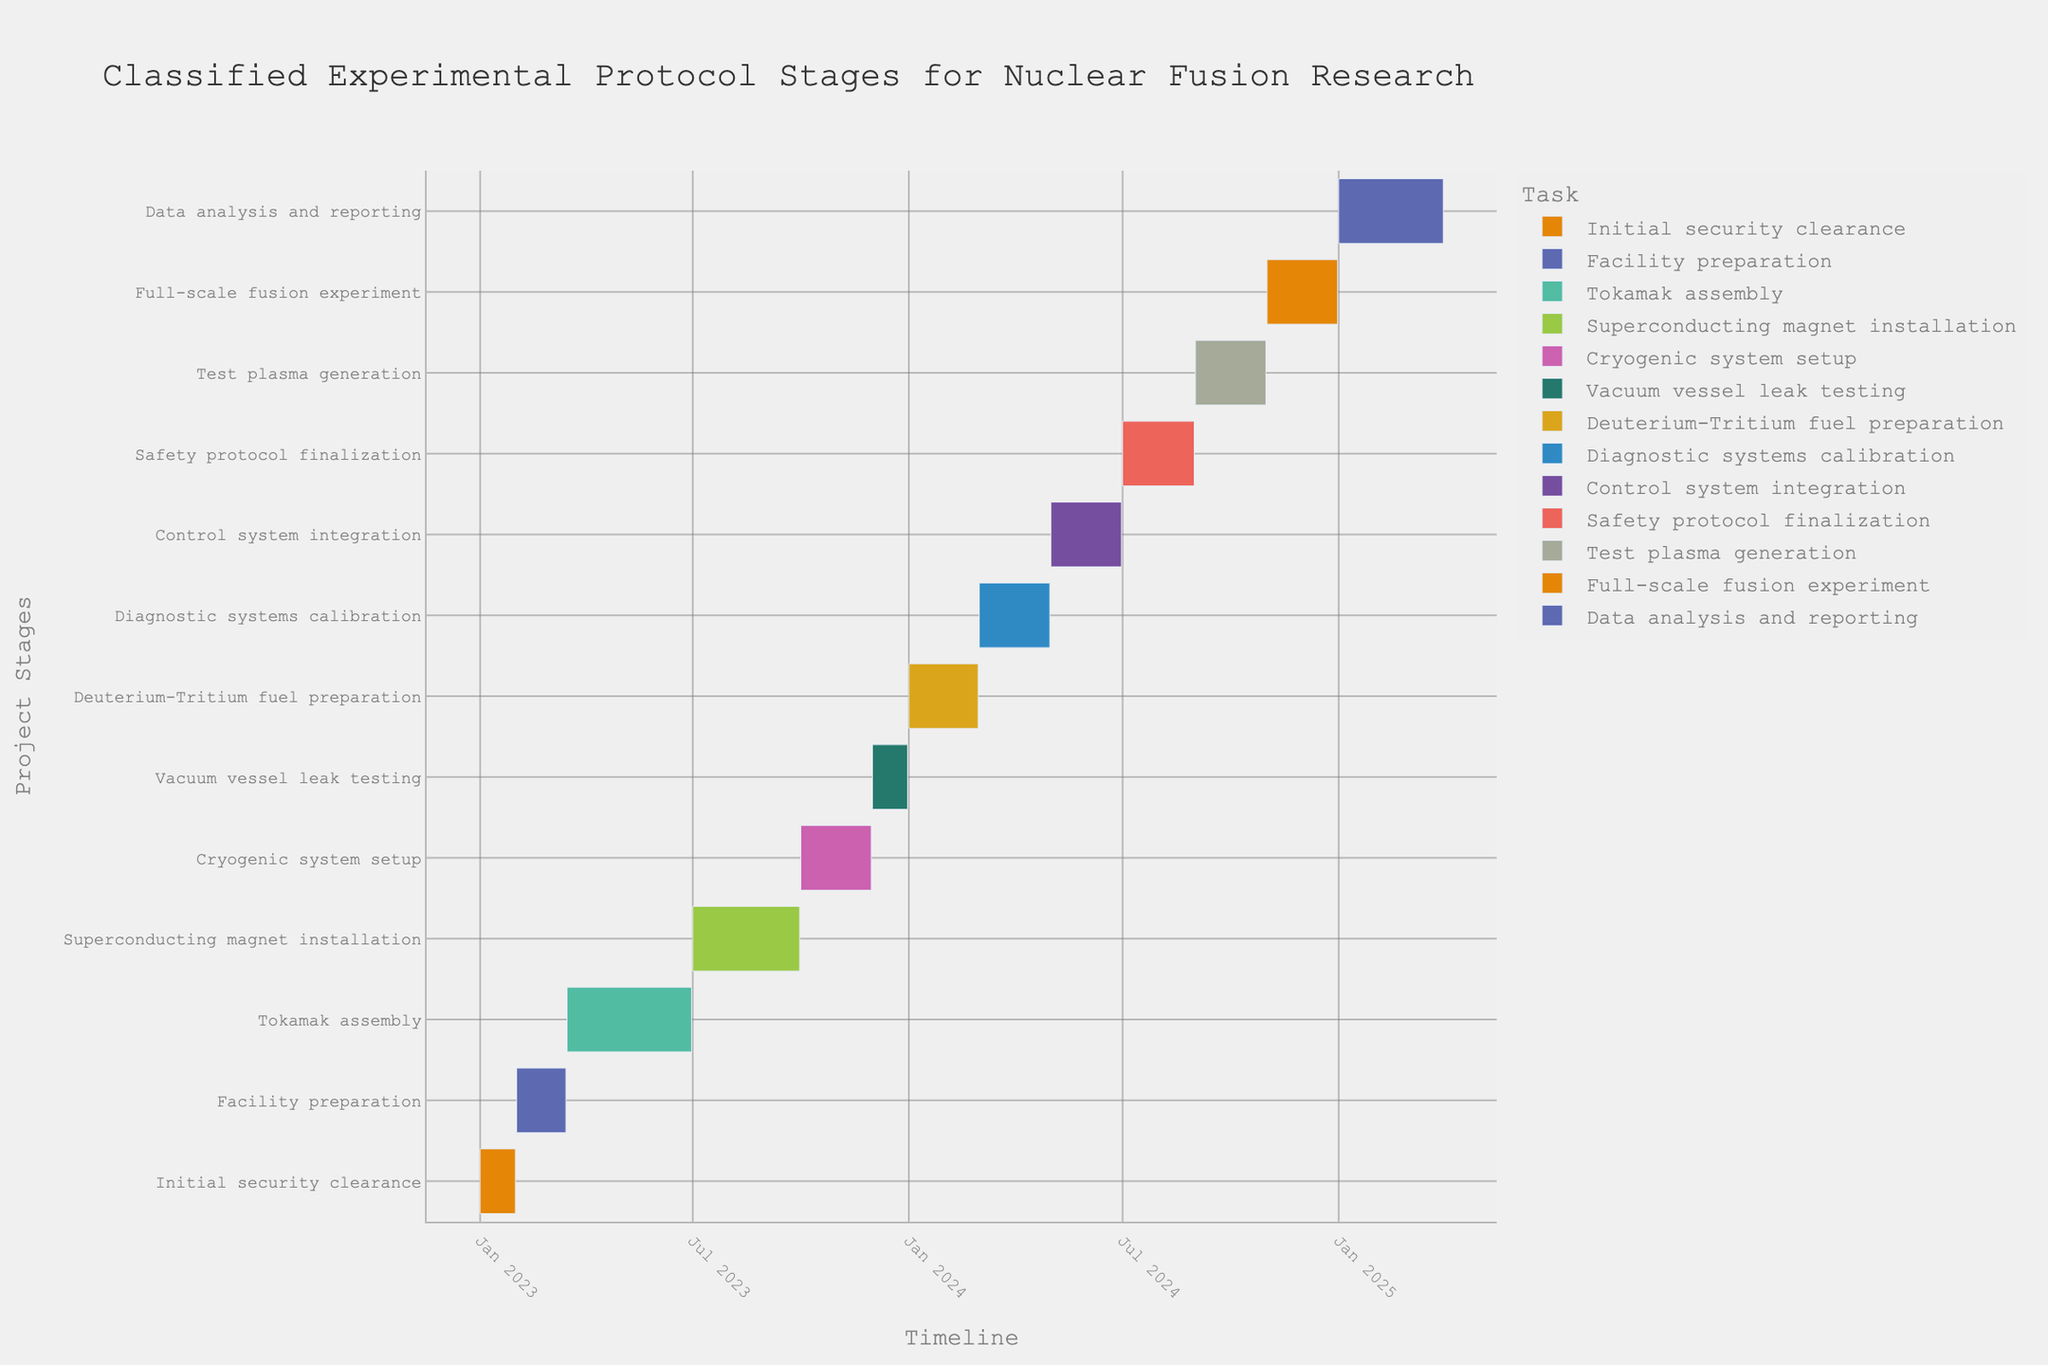What's the title of the Gantt chart? The title is located at the top of the chart. It summarizes the content depicted by the Gantt chart.
Answer: Classified Experimental Protocol Stages for Nuclear Fusion Research When does the "Tokamak assembly" stage start and end? Find the "Tokamak assembly" task on the chart and look at the start and end dates associated with it.
Answer: March 16, 2023 to June 30, 2023 Which stage directly follows "Facility preparation"? Identify the endpoint of "Facility preparation" and locate the next consecutive task starting after this date.
Answer: Tokamak assembly How long does the "Superconducting magnet installation" stage last? Determine the start and end dates of the "Superconducting magnet installation" task. Calculate the number of days between these dates.
Answer: 92 days What's the total duration of the project from the first stage to the final stage? Locate the start date of the first task ("Initial security clearance") and the end date of the last task ("Data analysis and reporting"). Calculate the duration between these dates.
Answer: 822 days During which months does the "Cryogenic system setup" occur? Look at the start and end dates of the "Cryogenic system setup" task and identify the months involved within this period.
Answer: October 2023 to November 2023 Which two tasks overlap in duration? Examine the start and end dates of each task to find any overlap where two tasks occur simultaneously.
Answer: Diagnostic systems calibration and Deuterium-Tritium fuel preparation What are the tasks that start in 2024? Identify tasks where the start date falls within the year 2024. List those tasks.
Answer: Deuterium-Tritium fuel preparation, Diagnostic systems calibration, Control system integration, Safety protocol finalization, Test plasma generation, Full-scale fusion experiment, Data analysis and reporting Which task has the shortest duration, and how long does it last? Compare the length of time each task lasts and identify the shortest one. Calculate its duration.
Answer: Vacuum vessel leak testing, 31 days How many tasks are planned to occur in the year 2023? Locate all tasks with at least part of their duration falling within the year 2023. Count these tasks.
Answer: Six tasks 